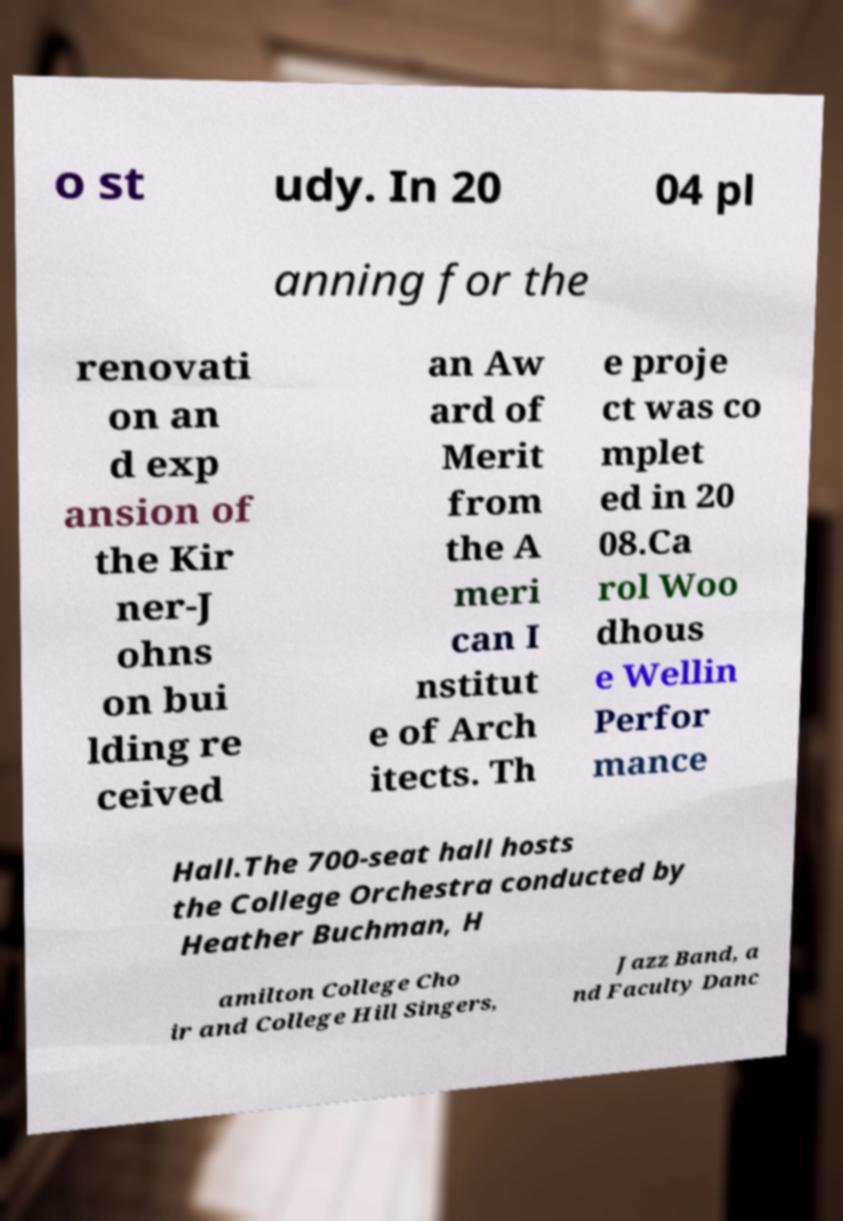I need the written content from this picture converted into text. Can you do that? o st udy. In 20 04 pl anning for the renovati on an d exp ansion of the Kir ner-J ohns on bui lding re ceived an Aw ard of Merit from the A meri can I nstitut e of Arch itects. Th e proje ct was co mplet ed in 20 08.Ca rol Woo dhous e Wellin Perfor mance Hall.The 700-seat hall hosts the College Orchestra conducted by Heather Buchman, H amilton College Cho ir and College Hill Singers, Jazz Band, a nd Faculty Danc 